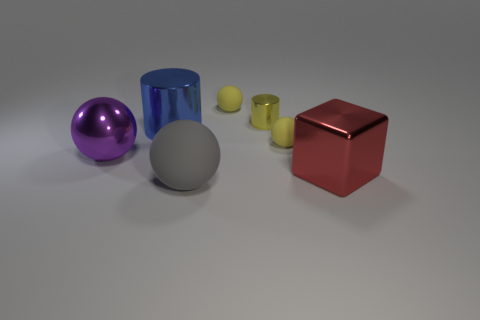Subtract all metal spheres. How many spheres are left? 3 Subtract all purple balls. How many balls are left? 3 Add 3 large cyan matte cubes. How many objects exist? 10 Subtract all brown cylinders. Subtract all cyan balls. How many cylinders are left? 2 Subtract all yellow cylinders. How many yellow balls are left? 2 Subtract all tiny cylinders. Subtract all yellow cylinders. How many objects are left? 5 Add 5 big gray objects. How many big gray objects are left? 6 Add 7 small cylinders. How many small cylinders exist? 8 Subtract 0 yellow blocks. How many objects are left? 7 Subtract all spheres. How many objects are left? 3 